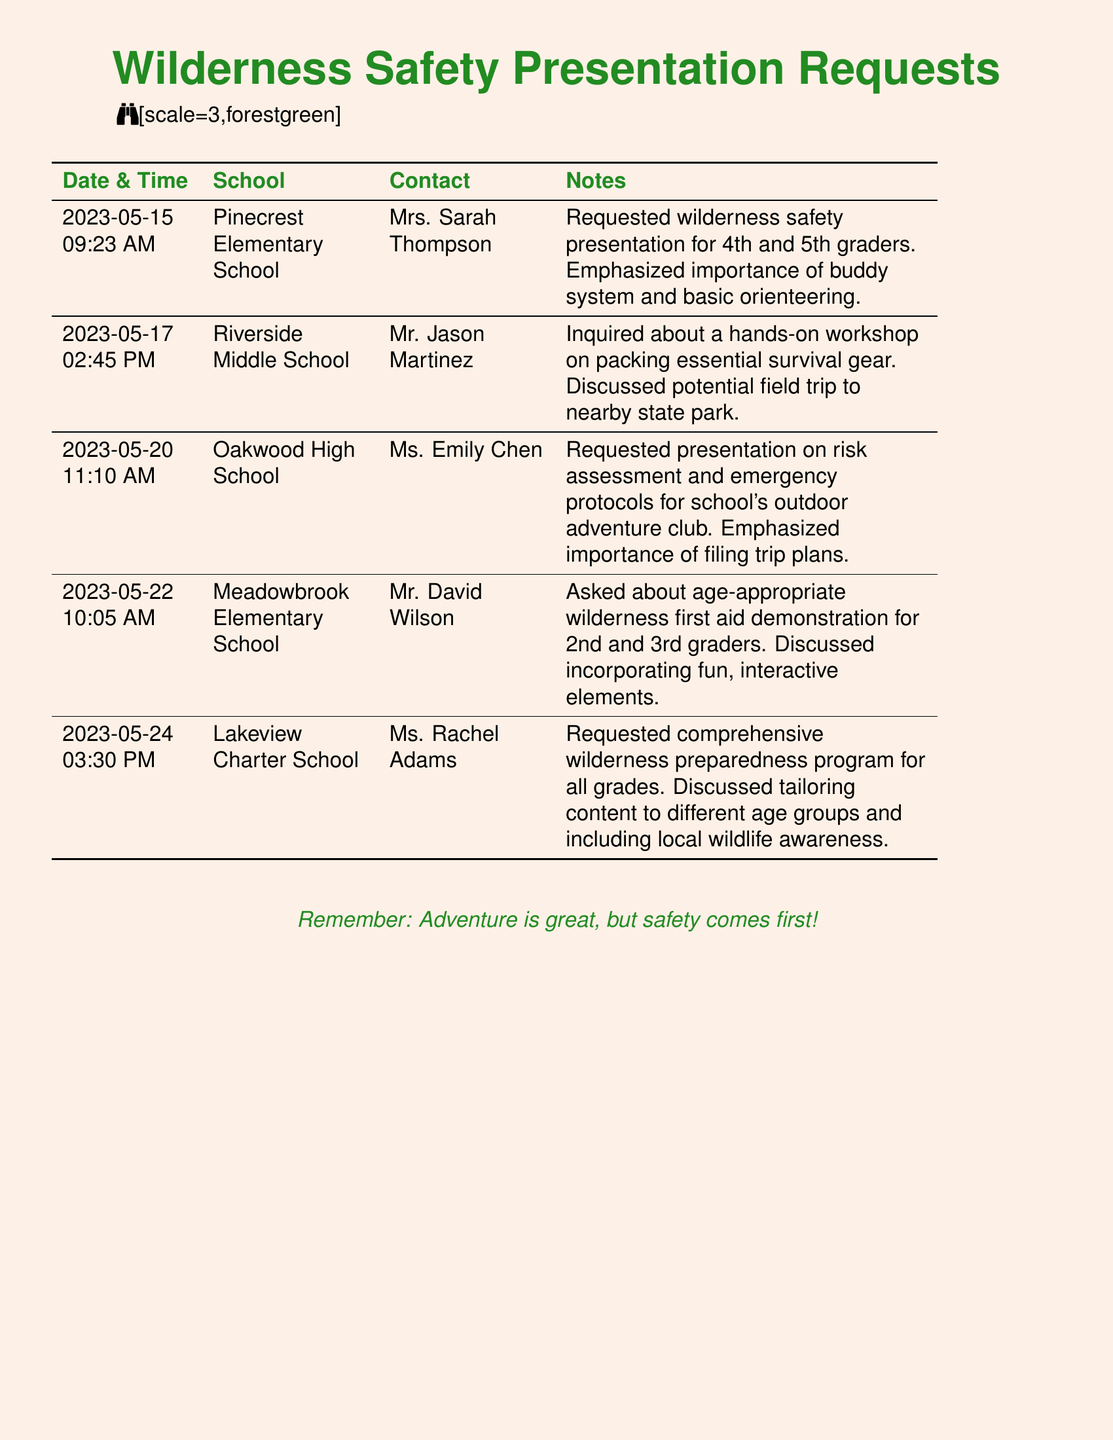What is the date of the first request? The first request in the document is listed under the date and time column.
Answer: 2023-05-15 Who is the contact person for Riverside Middle School? The contact person for Riverside Middle School is mentioned in the document under the contact column.
Answer: Mr. Jason Martinez What type of demonstration did Meadowbrook Elementary School request? The type of demonstration requested can be found in the notes for Meadowbrook Elementary School.
Answer: Wilderness first aid How many schools requested wilderness safety presentations? The total number of schools requesting presentations can be counted from the entries in the document.
Answer: Five What is emphasized for the outdoor adventure club presentation at Oakwood High School? The emphasis for the presentation is stated in the notes section for Oakwood High School.
Answer: Filing trip plans Which school discussed potential field trips? The school that discussed field trips can be inferred from the inquiry in the document.
Answer: Riverside Middle School 